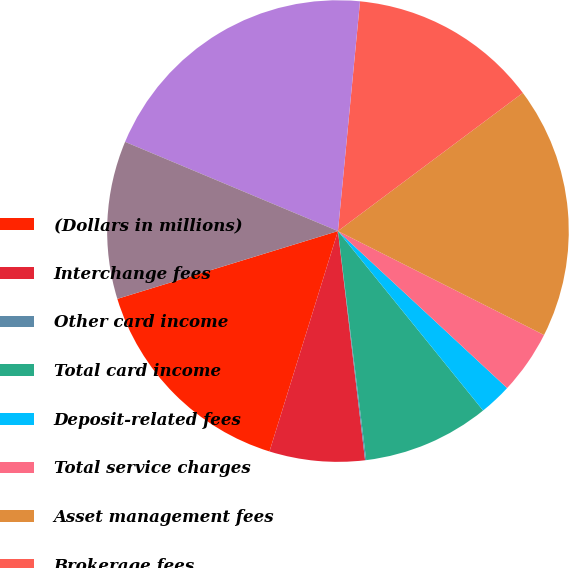<chart> <loc_0><loc_0><loc_500><loc_500><pie_chart><fcel>(Dollars in millions)<fcel>Interchange fees<fcel>Other card income<fcel>Total card income<fcel>Deposit-related fees<fcel>Total service charges<fcel>Asset management fees<fcel>Brokerage fees<fcel>Total investment and brokerage<fcel>Other income<nl><fcel>15.46%<fcel>6.67%<fcel>0.08%<fcel>8.87%<fcel>2.27%<fcel>4.47%<fcel>17.65%<fcel>13.26%<fcel>20.21%<fcel>11.06%<nl></chart> 